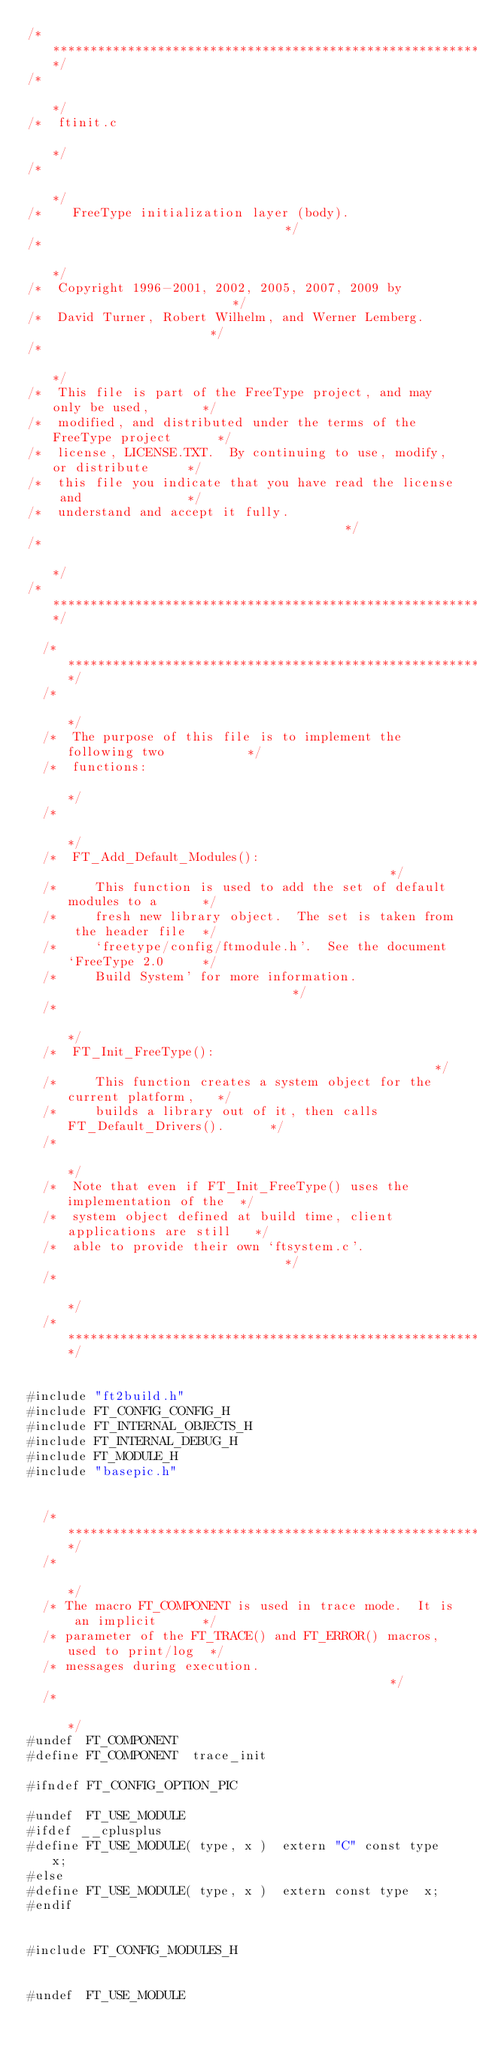Convert code to text. <code><loc_0><loc_0><loc_500><loc_500><_C_>/***************************************************************************/
/*                                                                         */
/*  ftinit.c                                                               */
/*                                                                         */
/*    FreeType initialization layer (body).                                */
/*                                                                         */
/*  Copyright 1996-2001, 2002, 2005, 2007, 2009 by                         */
/*  David Turner, Robert Wilhelm, and Werner Lemberg.                      */
/*                                                                         */
/*  This file is part of the FreeType project, and may only be used,       */
/*  modified, and distributed under the terms of the FreeType project      */
/*  license, LICENSE.TXT.  By continuing to use, modify, or distribute     */
/*  this file you indicate that you have read the license and              */
/*  understand and accept it fully.                                        */
/*                                                                         */
/***************************************************************************/

  /*************************************************************************/
  /*                                                                       */
  /*  The purpose of this file is to implement the following two           */
  /*  functions:                                                           */
  /*                                                                       */
  /*  FT_Add_Default_Modules():                                            */
  /*     This function is used to add the set of default modules to a      */
  /*     fresh new library object.  The set is taken from the header file  */
  /*     `freetype/config/ftmodule.h'.  See the document `FreeType 2.0     */
  /*     Build System' for more information.                               */
  /*                                                                       */
  /*  FT_Init_FreeType():                                                  */
  /*     This function creates a system object for the current platform,   */
  /*     builds a library out of it, then calls FT_Default_Drivers().      */
  /*                                                                       */
  /*  Note that even if FT_Init_FreeType() uses the implementation of the  */
  /*  system object defined at build time, client applications are still   */
  /*  able to provide their own `ftsystem.c'.                              */
  /*                                                                       */
  /*************************************************************************/


#include "ft2build.h"
#include FT_CONFIG_CONFIG_H
#include FT_INTERNAL_OBJECTS_H
#include FT_INTERNAL_DEBUG_H
#include FT_MODULE_H
#include "basepic.h"


  /*************************************************************************/
  /*                                                                       */
  /* The macro FT_COMPONENT is used in trace mode.  It is an implicit      */
  /* parameter of the FT_TRACE() and FT_ERROR() macros, used to print/log  */
  /* messages during execution.                                            */
  /*                                                                       */
#undef  FT_COMPONENT
#define FT_COMPONENT  trace_init

#ifndef FT_CONFIG_OPTION_PIC

#undef  FT_USE_MODULE
#ifdef __cplusplus
#define FT_USE_MODULE( type, x )  extern "C" const type  x;
#else
#define FT_USE_MODULE( type, x )  extern const type  x;
#endif


#include FT_CONFIG_MODULES_H


#undef  FT_USE_MODULE</code> 